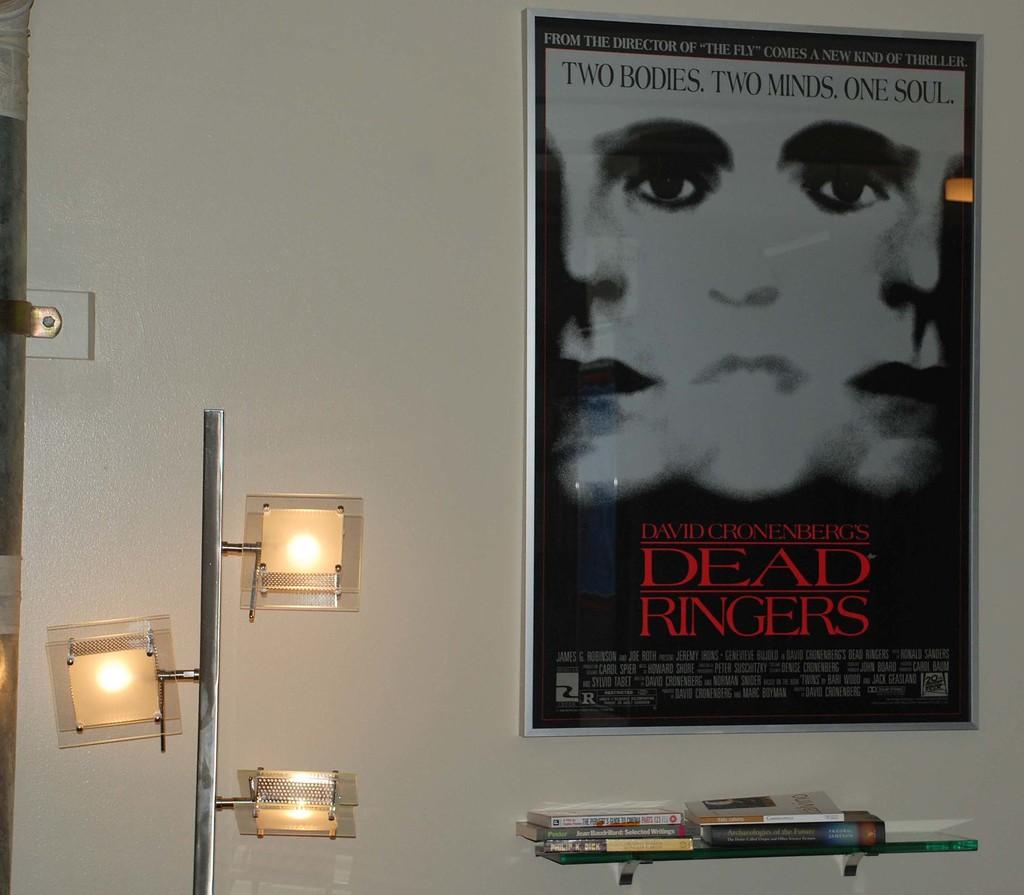What movie is on the poster?
Make the answer very short. Dead ringers. What age audience is this movie rated for?
Your answer should be very brief. R. 